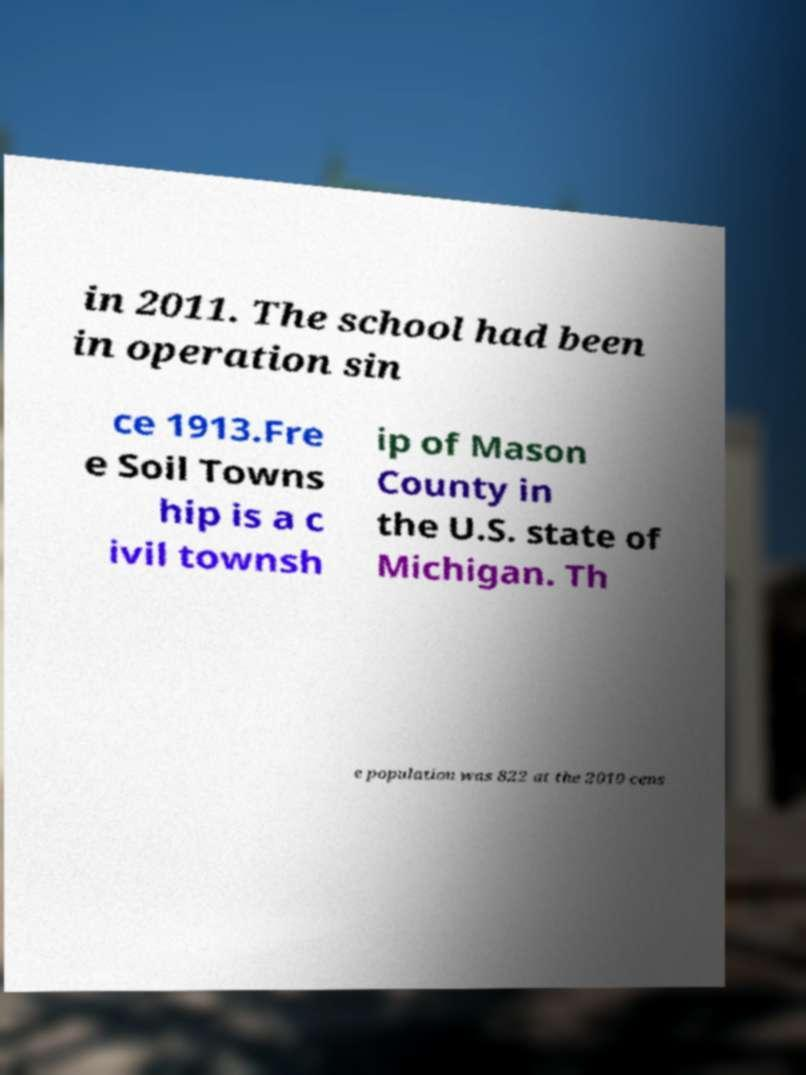Please identify and transcribe the text found in this image. in 2011. The school had been in operation sin ce 1913.Fre e Soil Towns hip is a c ivil townsh ip of Mason County in the U.S. state of Michigan. Th e population was 822 at the 2010 cens 